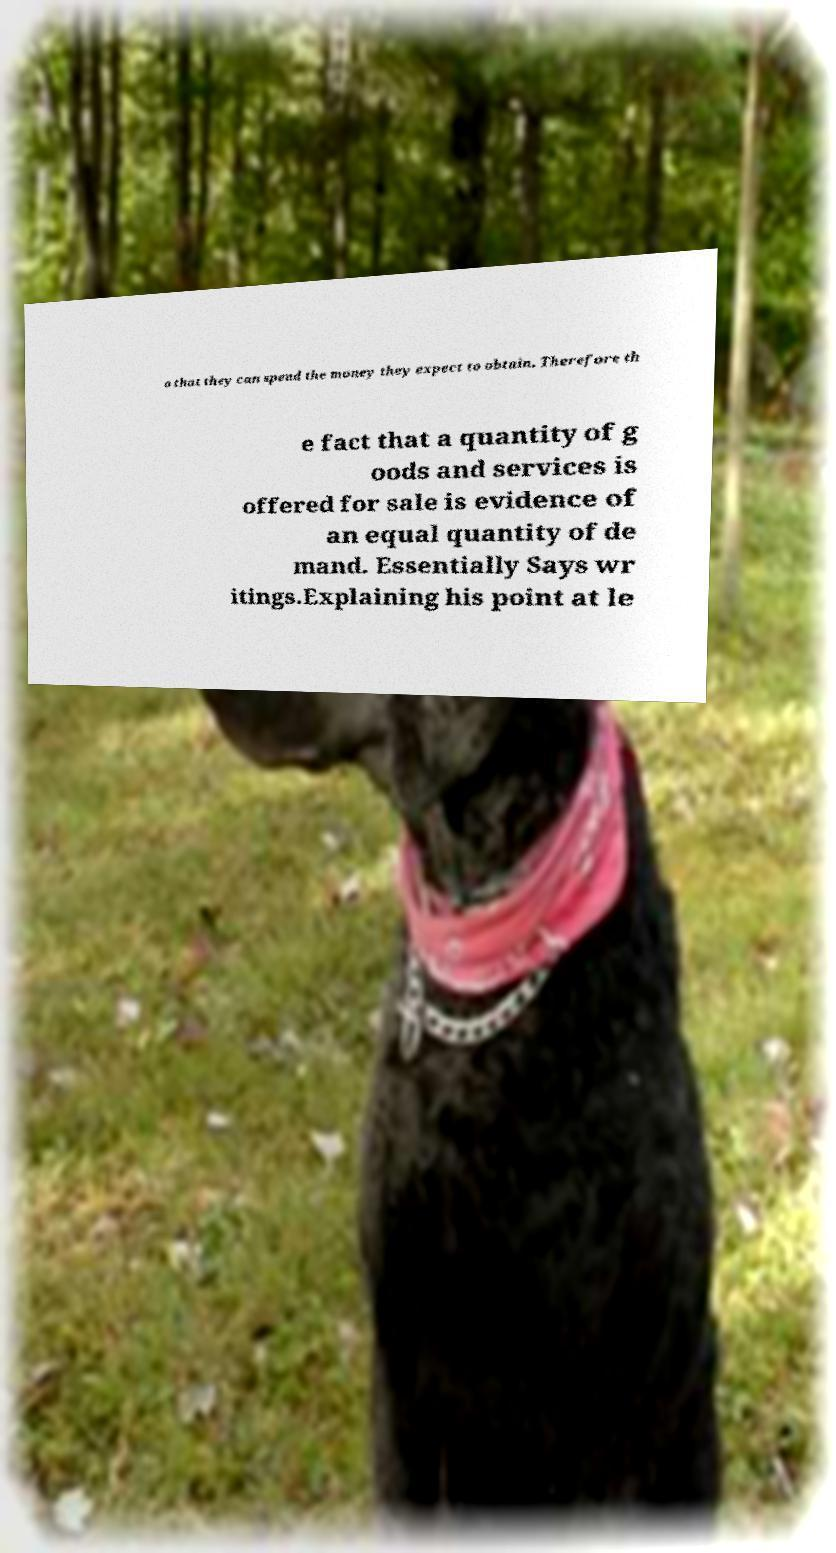There's text embedded in this image that I need extracted. Can you transcribe it verbatim? o that they can spend the money they expect to obtain. Therefore th e fact that a quantity of g oods and services is offered for sale is evidence of an equal quantity of de mand. Essentially Says wr itings.Explaining his point at le 